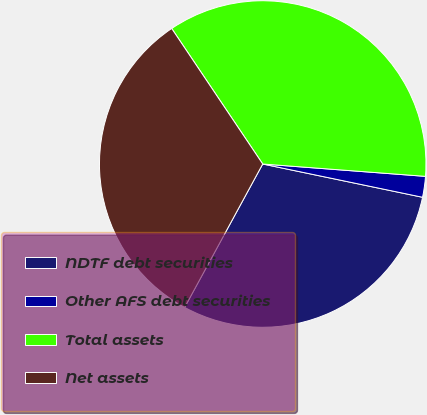Convert chart. <chart><loc_0><loc_0><loc_500><loc_500><pie_chart><fcel>NDTF debt securities<fcel>Other AFS debt securities<fcel>Total assets<fcel>Net assets<nl><fcel>29.67%<fcel>2.06%<fcel>35.62%<fcel>32.65%<nl></chart> 